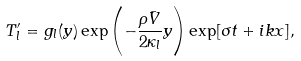<formula> <loc_0><loc_0><loc_500><loc_500>T ^ { \prime } _ { l } = g _ { l } ( y ) \exp \left ( - \frac { \rho \bar { V } } { 2 \kappa _ { l } } y \right ) \exp [ \sigma t + i k x ] ,</formula> 